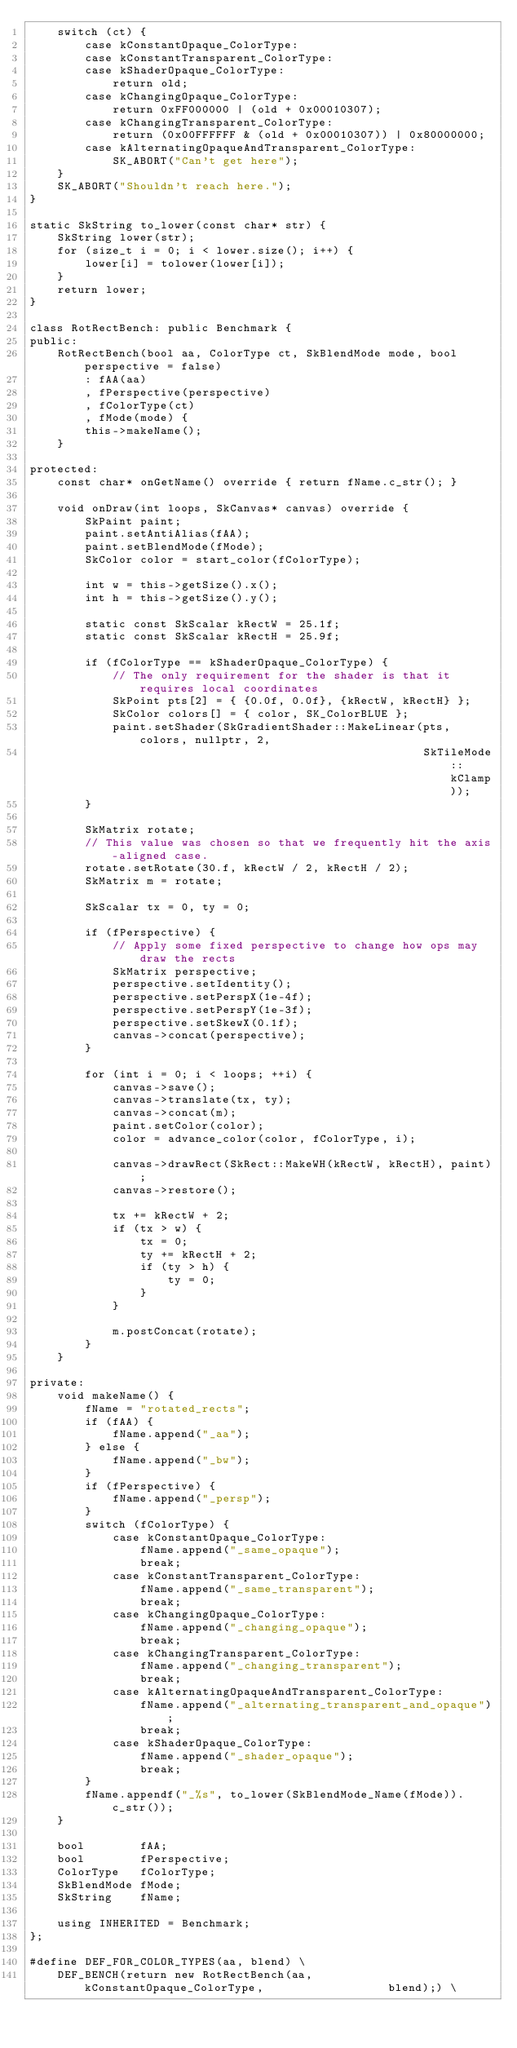<code> <loc_0><loc_0><loc_500><loc_500><_C++_>    switch (ct) {
        case kConstantOpaque_ColorType:
        case kConstantTransparent_ColorType:
        case kShaderOpaque_ColorType:
            return old;
        case kChangingOpaque_ColorType:
            return 0xFF000000 | (old + 0x00010307);
        case kChangingTransparent_ColorType:
            return (0x00FFFFFF & (old + 0x00010307)) | 0x80000000;
        case kAlternatingOpaqueAndTransparent_ColorType:
            SK_ABORT("Can't get here");
    }
    SK_ABORT("Shouldn't reach here.");
}

static SkString to_lower(const char* str) {
    SkString lower(str);
    for (size_t i = 0; i < lower.size(); i++) {
        lower[i] = tolower(lower[i]);
    }
    return lower;
}

class RotRectBench: public Benchmark {
public:
    RotRectBench(bool aa, ColorType ct, SkBlendMode mode, bool perspective = false)
        : fAA(aa)
        , fPerspective(perspective)
        , fColorType(ct)
        , fMode(mode) {
        this->makeName();
    }

protected:
    const char* onGetName() override { return fName.c_str(); }

    void onDraw(int loops, SkCanvas* canvas) override {
        SkPaint paint;
        paint.setAntiAlias(fAA);
        paint.setBlendMode(fMode);
        SkColor color = start_color(fColorType);

        int w = this->getSize().x();
        int h = this->getSize().y();

        static const SkScalar kRectW = 25.1f;
        static const SkScalar kRectH = 25.9f;

        if (fColorType == kShaderOpaque_ColorType) {
            // The only requirement for the shader is that it requires local coordinates
            SkPoint pts[2] = { {0.0f, 0.0f}, {kRectW, kRectH} };
            SkColor colors[] = { color, SK_ColorBLUE };
            paint.setShader(SkGradientShader::MakeLinear(pts, colors, nullptr, 2,
                                                         SkTileMode::kClamp));
        }

        SkMatrix rotate;
        // This value was chosen so that we frequently hit the axis-aligned case.
        rotate.setRotate(30.f, kRectW / 2, kRectH / 2);
        SkMatrix m = rotate;

        SkScalar tx = 0, ty = 0;

        if (fPerspective) {
            // Apply some fixed perspective to change how ops may draw the rects
            SkMatrix perspective;
            perspective.setIdentity();
            perspective.setPerspX(1e-4f);
            perspective.setPerspY(1e-3f);
            perspective.setSkewX(0.1f);
            canvas->concat(perspective);
        }

        for (int i = 0; i < loops; ++i) {
            canvas->save();
            canvas->translate(tx, ty);
            canvas->concat(m);
            paint.setColor(color);
            color = advance_color(color, fColorType, i);

            canvas->drawRect(SkRect::MakeWH(kRectW, kRectH), paint);
            canvas->restore();

            tx += kRectW + 2;
            if (tx > w) {
                tx = 0;
                ty += kRectH + 2;
                if (ty > h) {
                    ty = 0;
                }
            }

            m.postConcat(rotate);
        }
    }

private:
    void makeName() {
        fName = "rotated_rects";
        if (fAA) {
            fName.append("_aa");
        } else {
            fName.append("_bw");
        }
        if (fPerspective) {
            fName.append("_persp");
        }
        switch (fColorType) {
            case kConstantOpaque_ColorType:
                fName.append("_same_opaque");
                break;
            case kConstantTransparent_ColorType:
                fName.append("_same_transparent");
                break;
            case kChangingOpaque_ColorType:
                fName.append("_changing_opaque");
                break;
            case kChangingTransparent_ColorType:
                fName.append("_changing_transparent");
                break;
            case kAlternatingOpaqueAndTransparent_ColorType:
                fName.append("_alternating_transparent_and_opaque");
                break;
            case kShaderOpaque_ColorType:
                fName.append("_shader_opaque");
                break;
        }
        fName.appendf("_%s", to_lower(SkBlendMode_Name(fMode)).c_str());
    }

    bool        fAA;
    bool        fPerspective;
    ColorType   fColorType;
    SkBlendMode fMode;
    SkString    fName;

    using INHERITED = Benchmark;
};

#define DEF_FOR_COLOR_TYPES(aa, blend) \
    DEF_BENCH(return new RotRectBench(aa,  kConstantOpaque_ColorType,                  blend);) \</code> 